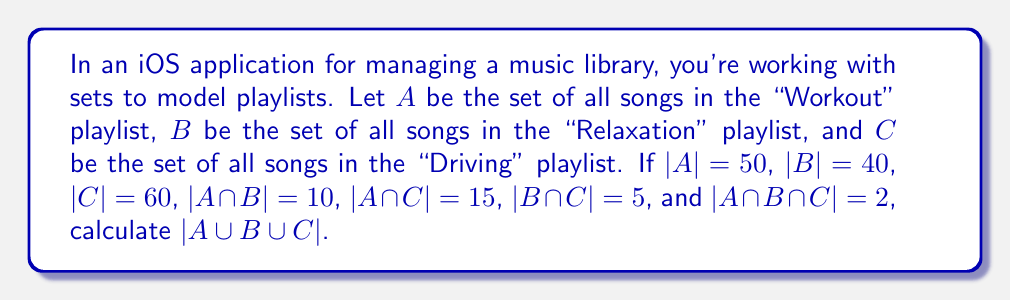Can you solve this math problem? To solve this problem, we'll use the Inclusion-Exclusion Principle for three sets:

$$|A \cup B \cup C| = |A| + |B| + |C| - |A \cap B| - |A \cap C| - |B \cap C| + |A \cap B \cap C|$$

Let's substitute the given values:

1. $|A| = 50$
2. $|B| = 40$
3. $|C| = 60$
4. $|A \cap B| = 10$
5. $|A \cap C| = 15$
6. $|B \cap C| = 5$
7. $|A \cap B \cap C| = 2$

Now, let's calculate:

$$\begin{align*}
|A \cup B \cup C| &= 50 + 40 + 60 - 10 - 15 - 5 + 2 \\
&= 150 - 30 + 2 \\
&= 122
\end{align*}$$

Therefore, the total number of unique songs in all three playlists is 122.
Answer: $|A \cup B \cup C| = 122$ 